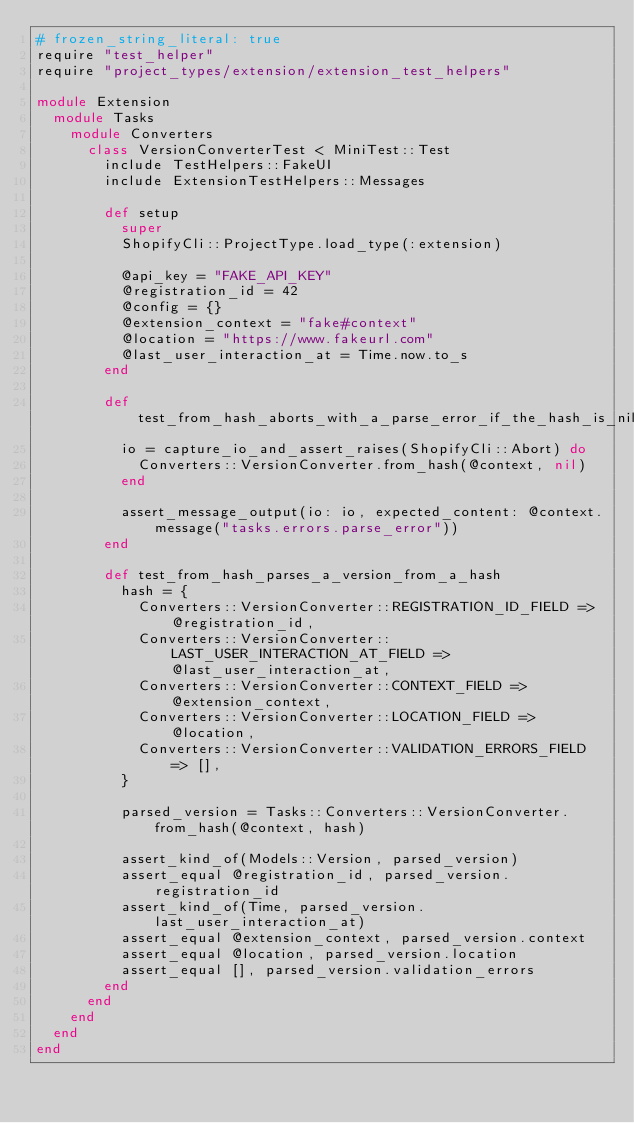Convert code to text. <code><loc_0><loc_0><loc_500><loc_500><_Ruby_># frozen_string_literal: true
require "test_helper"
require "project_types/extension/extension_test_helpers"

module Extension
  module Tasks
    module Converters
      class VersionConverterTest < MiniTest::Test
        include TestHelpers::FakeUI
        include ExtensionTestHelpers::Messages

        def setup
          super
          ShopifyCli::ProjectType.load_type(:extension)

          @api_key = "FAKE_API_KEY"
          @registration_id = 42
          @config = {}
          @extension_context = "fake#context"
          @location = "https://www.fakeurl.com"
          @last_user_interaction_at = Time.now.to_s
        end

        def test_from_hash_aborts_with_a_parse_error_if_the_hash_is_nil
          io = capture_io_and_assert_raises(ShopifyCli::Abort) do
            Converters::VersionConverter.from_hash(@context, nil)
          end

          assert_message_output(io: io, expected_content: @context.message("tasks.errors.parse_error"))
        end

        def test_from_hash_parses_a_version_from_a_hash
          hash = {
            Converters::VersionConverter::REGISTRATION_ID_FIELD => @registration_id,
            Converters::VersionConverter::LAST_USER_INTERACTION_AT_FIELD => @last_user_interaction_at,
            Converters::VersionConverter::CONTEXT_FIELD => @extension_context,
            Converters::VersionConverter::LOCATION_FIELD => @location,
            Converters::VersionConverter::VALIDATION_ERRORS_FIELD => [],
          }

          parsed_version = Tasks::Converters::VersionConverter.from_hash(@context, hash)

          assert_kind_of(Models::Version, parsed_version)
          assert_equal @registration_id, parsed_version.registration_id
          assert_kind_of(Time, parsed_version.last_user_interaction_at)
          assert_equal @extension_context, parsed_version.context
          assert_equal @location, parsed_version.location
          assert_equal [], parsed_version.validation_errors
        end
      end
    end
  end
end
</code> 